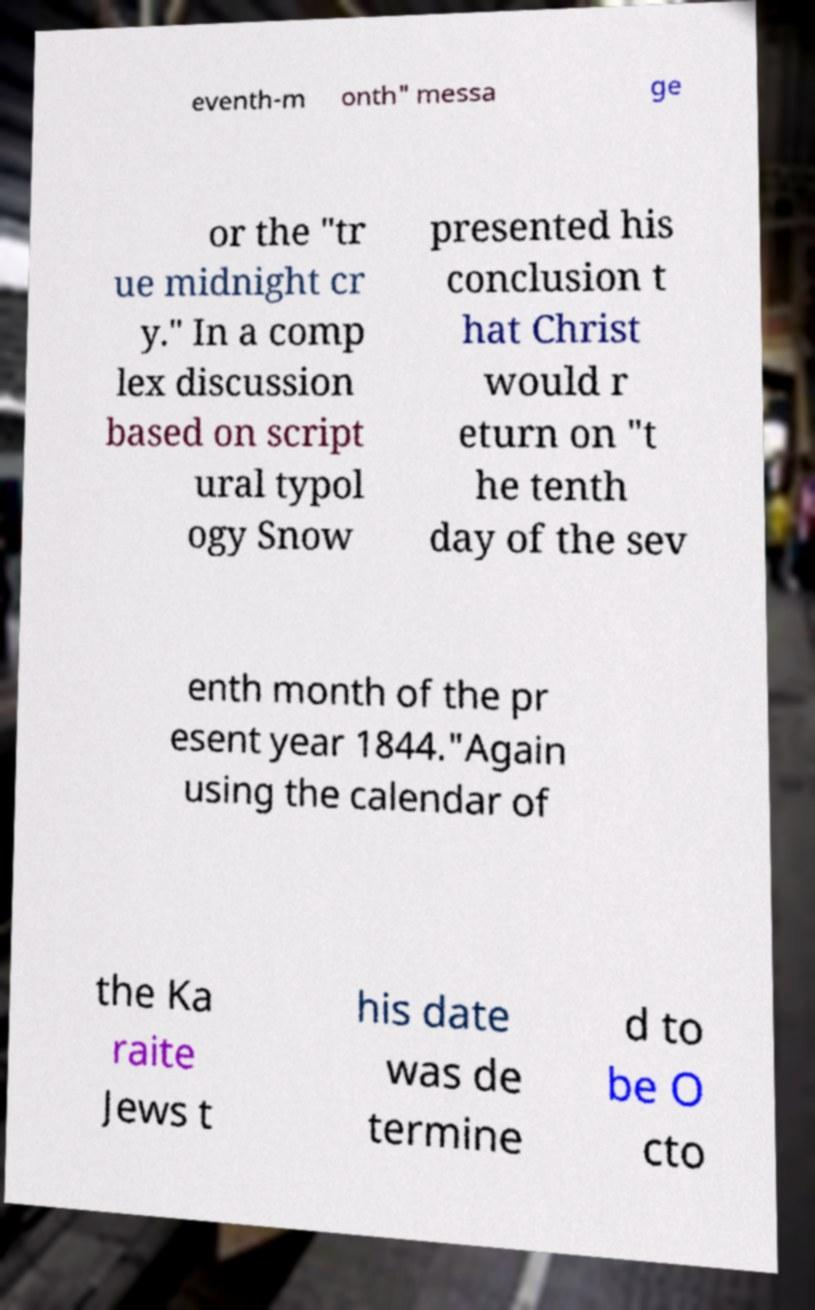I need the written content from this picture converted into text. Can you do that? eventh-m onth" messa ge or the "tr ue midnight cr y." In a comp lex discussion based on script ural typol ogy Snow presented his conclusion t hat Christ would r eturn on "t he tenth day of the sev enth month of the pr esent year 1844."Again using the calendar of the Ka raite Jews t his date was de termine d to be O cto 